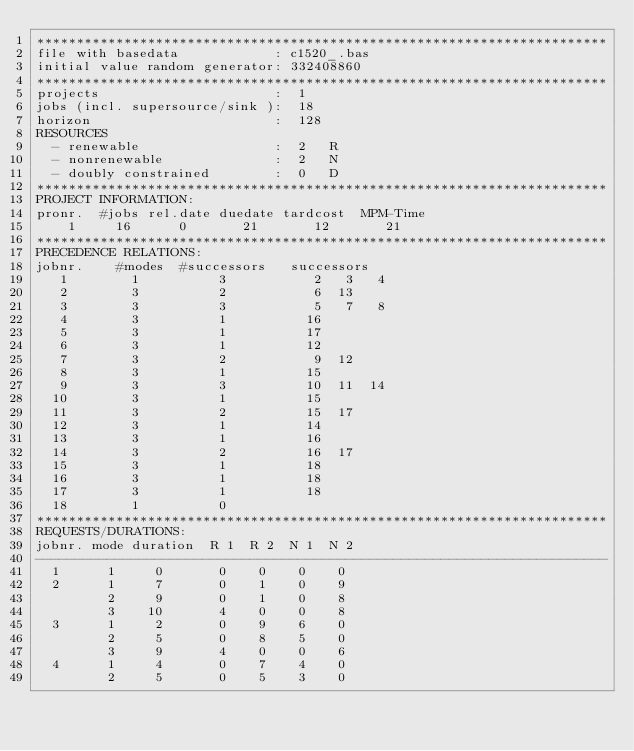Convert code to text. <code><loc_0><loc_0><loc_500><loc_500><_ObjectiveC_>************************************************************************
file with basedata            : c1520_.bas
initial value random generator: 332408860
************************************************************************
projects                      :  1
jobs (incl. supersource/sink ):  18
horizon                       :  128
RESOURCES
  - renewable                 :  2   R
  - nonrenewable              :  2   N
  - doubly constrained        :  0   D
************************************************************************
PROJECT INFORMATION:
pronr.  #jobs rel.date duedate tardcost  MPM-Time
    1     16      0       21       12       21
************************************************************************
PRECEDENCE RELATIONS:
jobnr.    #modes  #successors   successors
   1        1          3           2   3   4
   2        3          2           6  13
   3        3          3           5   7   8
   4        3          1          16
   5        3          1          17
   6        3          1          12
   7        3          2           9  12
   8        3          1          15
   9        3          3          10  11  14
  10        3          1          15
  11        3          2          15  17
  12        3          1          14
  13        3          1          16
  14        3          2          16  17
  15        3          1          18
  16        3          1          18
  17        3          1          18
  18        1          0        
************************************************************************
REQUESTS/DURATIONS:
jobnr. mode duration  R 1  R 2  N 1  N 2
------------------------------------------------------------------------
  1      1     0       0    0    0    0
  2      1     7       0    1    0    9
         2     9       0    1    0    8
         3    10       4    0    0    8
  3      1     2       0    9    6    0
         2     5       0    8    5    0
         3     9       4    0    0    6
  4      1     4       0    7    4    0
         2     5       0    5    3    0</code> 